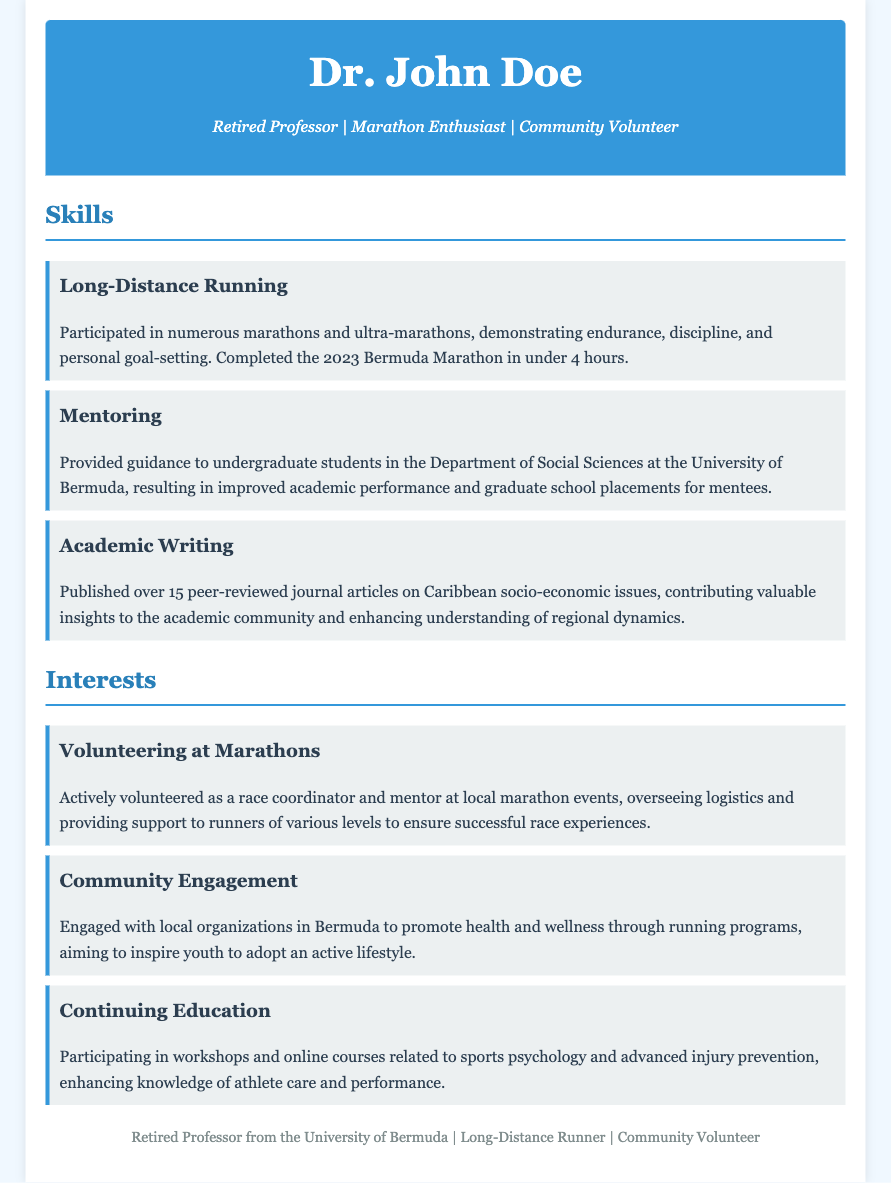What is the name of the retired professor? The name is listed in the header section of the document.
Answer: Dr. John Doe How many peer-reviewed journal articles has he published? The number of articles is mentioned in the Academic Writing section.
Answer: Over 15 What marathon did he complete in under 4 hours? This specific marathon is noted in the Long-Distance Running skill section.
Answer: 2023 Bermuda Marathon What role did he serve at local marathon events? The document specifies his involvement in the interests section.
Answer: Race coordinator In which department did he mentor undergraduate students? The department is mentioned under the Mentoring skill.
Answer: Department of Social Sciences What does he aim to promote through community engagement? The goals for community engagement are outlined in the interests section.
Answer: Health and wellness What additional topics is he participating in workshops about? The interests section mentions his continuing education efforts.
Answer: Sports psychology and advanced injury prevention 